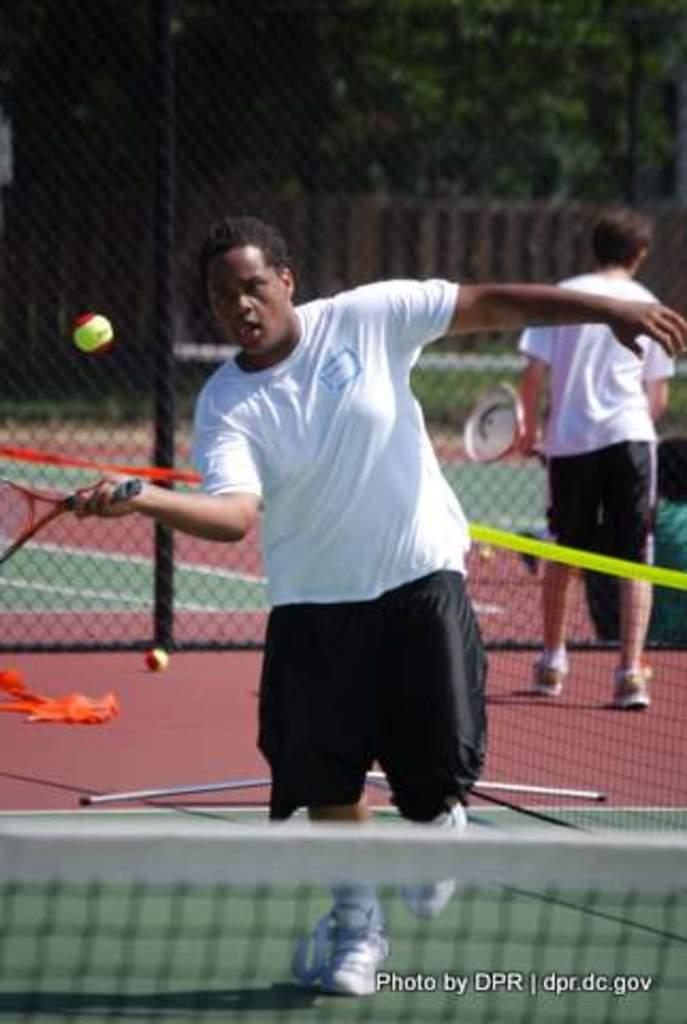What is present in the image that serves as a barrier or divider? There is a fence in the image. How many people are in the image? There are two people in the image. What are the people holding in their hands? The people are holding tennis rackets. What color are the t-shirts worn by the people? The people are wearing white t-shirts. What can be seen in the background of the image? There are trees in the background of the image. Where is the quince located in the image? There is no quince present in the image. How do the people plan to join the tennis club in the image? The image does not provide information about the people joining a tennis club. What type of food is being served in the lunchroom in the image? There is no lunchroom present in the image. 